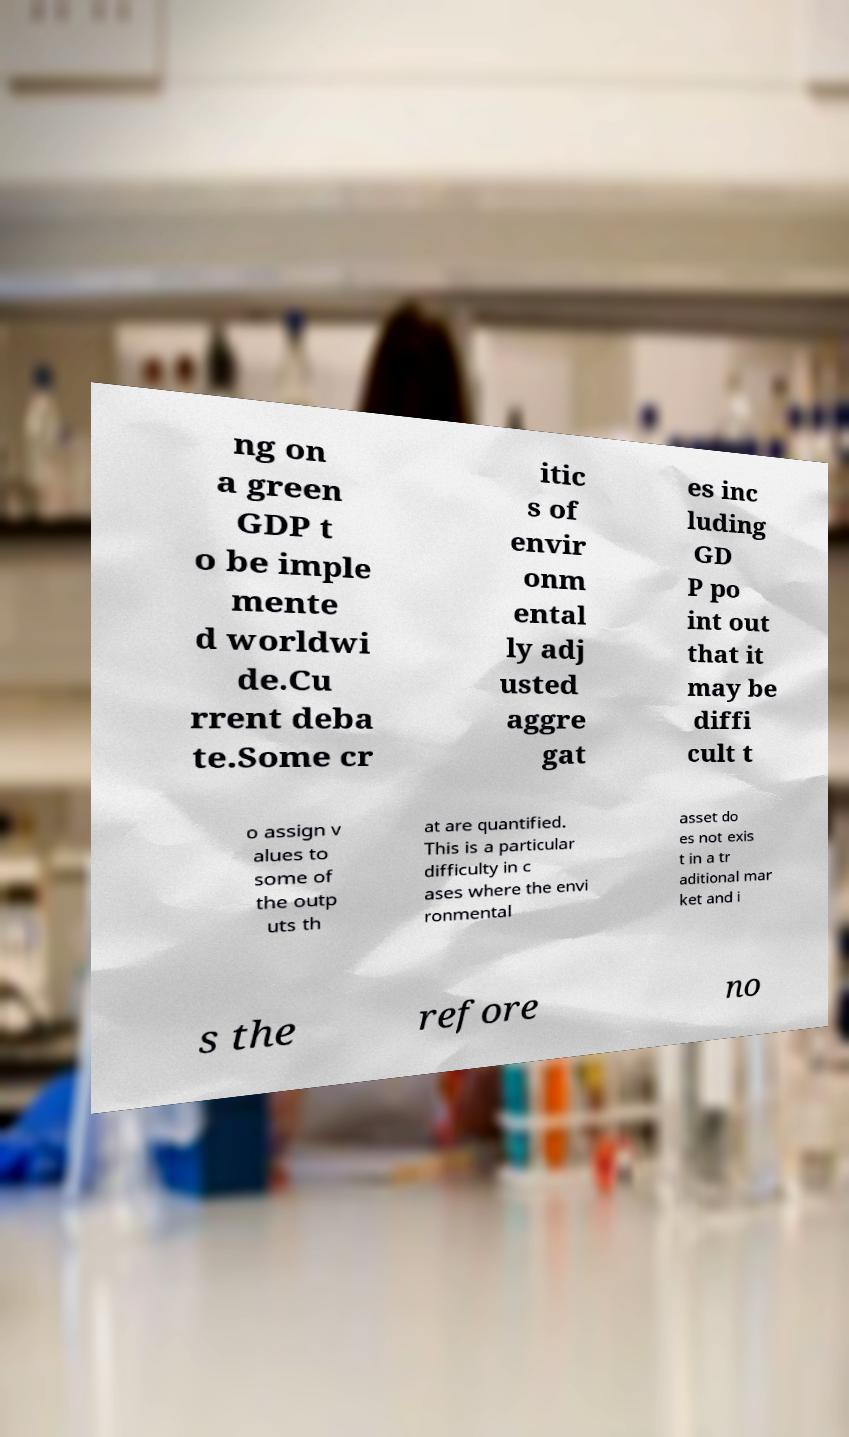I need the written content from this picture converted into text. Can you do that? ng on a green GDP t o be imple mente d worldwi de.Cu rrent deba te.Some cr itic s of envir onm ental ly adj usted aggre gat es inc luding GD P po int out that it may be diffi cult t o assign v alues to some of the outp uts th at are quantified. This is a particular difficulty in c ases where the envi ronmental asset do es not exis t in a tr aditional mar ket and i s the refore no 